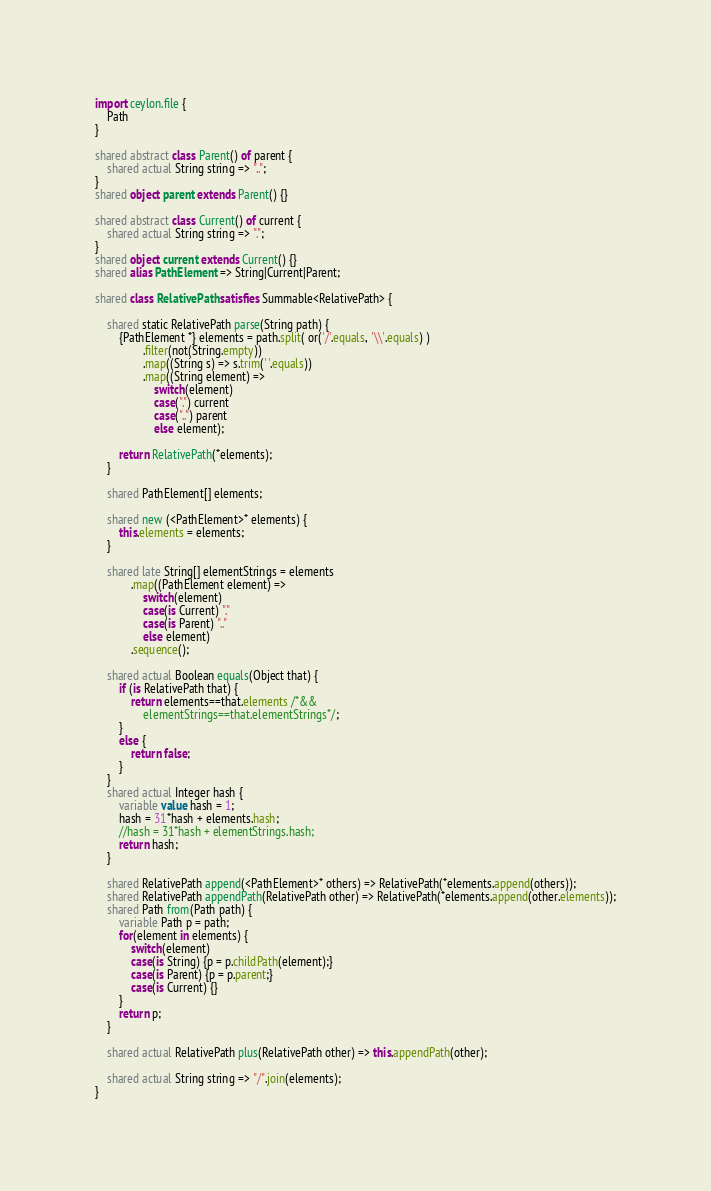<code> <loc_0><loc_0><loc_500><loc_500><_Ceylon_>import ceylon.file {
	Path
}

shared abstract class Parent() of parent {
	shared actual String string => "..";
}
shared object parent extends Parent() {}

shared abstract class Current() of current {
	shared actual String string => ".";
}
shared object current extends Current() {}
shared alias PathElement => String|Current|Parent;

shared class RelativePath satisfies Summable<RelativePath> {

	shared static RelativePath parse(String path) {
		{PathElement *} elements = path.split( or('/'.equals, '\\'.equals) )
				.filter(not(String.empty))
				.map((String s) => s.trim(' '.equals))
				.map((String element) => 
					switch(element)
					case(".") current
					case("..") parent
					else element);
		
		return RelativePath(*elements);
	}

	shared PathElement[] elements;
	
	shared new (<PathElement>* elements) {
		this.elements = elements;
	}
	
	shared late String[] elementStrings = elements
			.map((PathElement element) => 
				switch(element) 
				case(is Current) "." 
				case(is Parent) ".." 
				else element)
			.sequence();
	
	shared actual Boolean equals(Object that) {
		if (is RelativePath that) {
			return elements==that.elements /*&& 
				elementStrings==that.elementStrings*/;
		}
		else {
			return false;
		}
	}
	shared actual Integer hash {
		variable value hash = 1;
		hash = 31*hash + elements.hash;
		//hash = 31*hash + elementStrings.hash;
		return hash;
	}
	
	shared RelativePath append(<PathElement>* others) => RelativePath(*elements.append(others)); 
	shared RelativePath appendPath(RelativePath other) => RelativePath(*elements.append(other.elements));
	shared Path from(Path path) {
		variable Path p = path;
		for(element in elements) {
			switch(element)
			case(is String) {p = p.childPath(element);}
			case(is Parent) {p = p.parent;}
			case(is Current) {}
		}
		return p;
	}
	
	shared actual RelativePath plus(RelativePath other) => this.appendPath(other);
	
	shared actual String string => "/".join(elements);
}</code> 